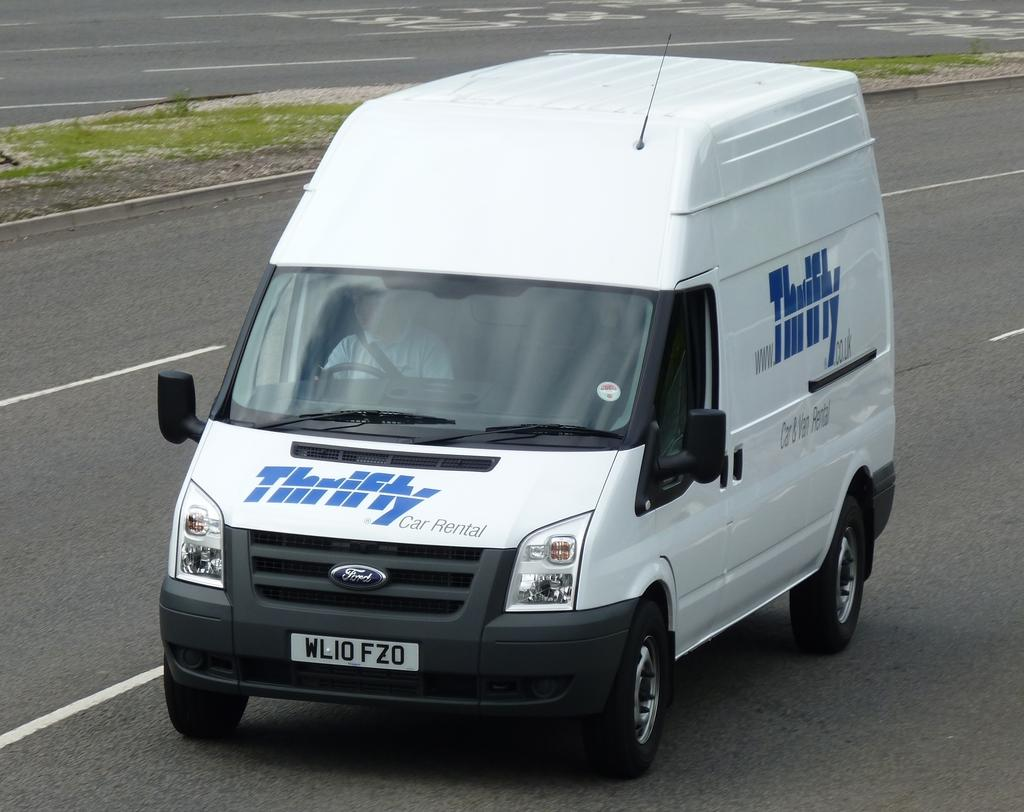<image>
Relay a brief, clear account of the picture shown. the word thrifty that is on a van 